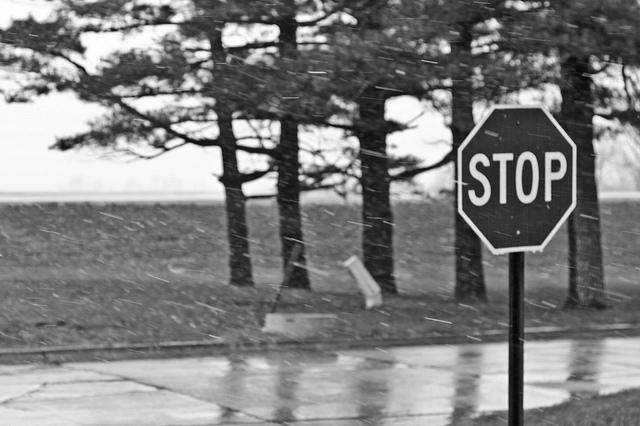What is the common object that is covering the grassy area near the post?
Be succinct. Trees. Is it raining?
Quick response, please. Yes. Is this image in black and white?
Quick response, please. Yes. Is this a regular stop sign?
Quick response, please. Yes. Is the grass green or brown?
Keep it brief. Green. What does the sign say?
Be succinct. Stop. Has it been raining?
Answer briefly. Yes. What is the scene?
Give a very brief answer. Raining on street. Is this photo in color or black and white?
Write a very short answer. Black and white. 